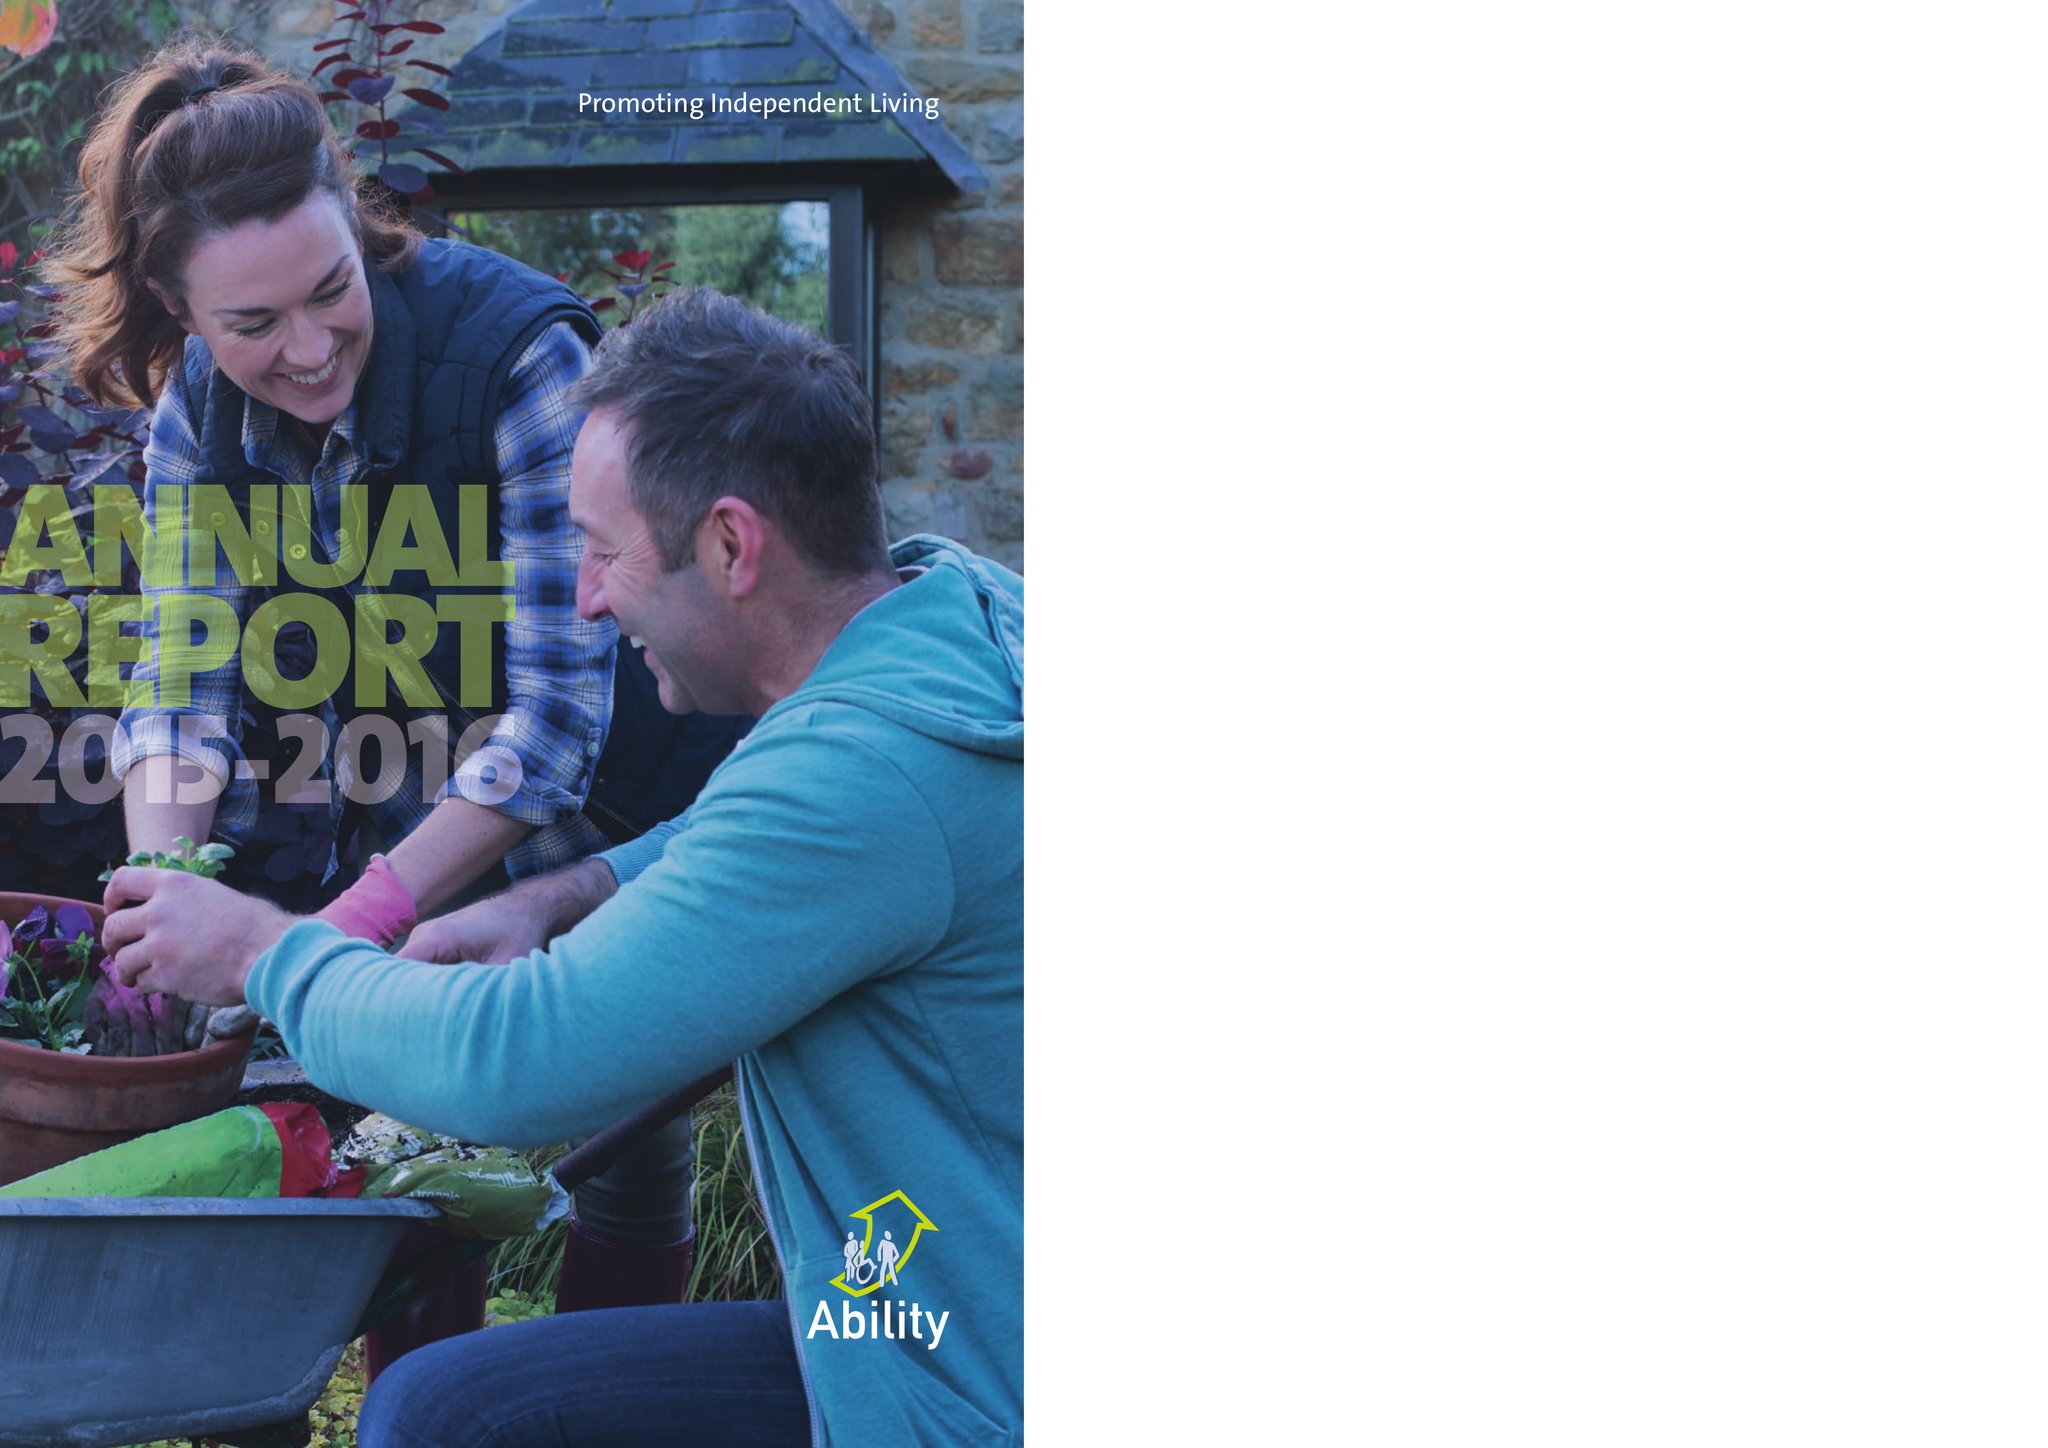What is the value for the charity_name?
Answer the question using a single word or phrase. Ability Housing Association 